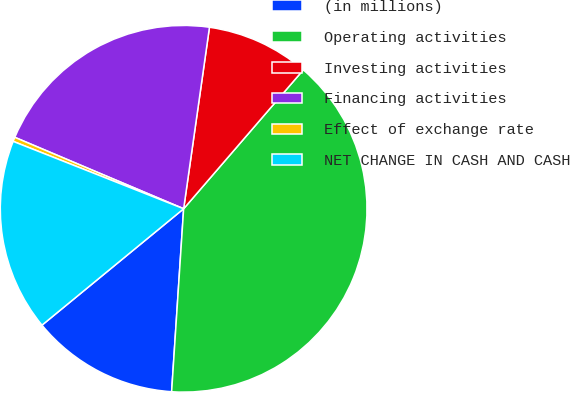<chart> <loc_0><loc_0><loc_500><loc_500><pie_chart><fcel>(in millions)<fcel>Operating activities<fcel>Investing activities<fcel>Financing activities<fcel>Effect of exchange rate<fcel>NET CHANGE IN CASH AND CASH<nl><fcel>13.01%<fcel>39.73%<fcel>9.07%<fcel>20.88%<fcel>0.38%<fcel>16.94%<nl></chart> 